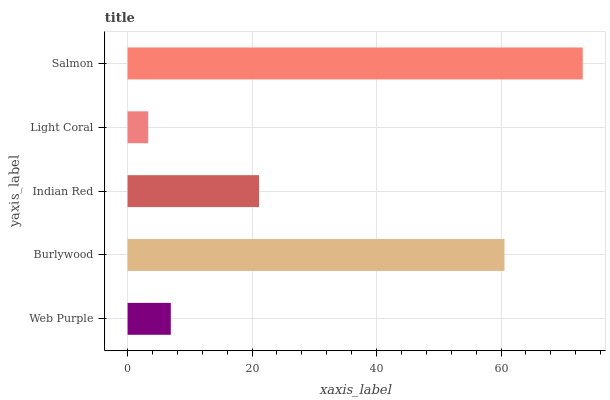Is Light Coral the minimum?
Answer yes or no. Yes. Is Salmon the maximum?
Answer yes or no. Yes. Is Burlywood the minimum?
Answer yes or no. No. Is Burlywood the maximum?
Answer yes or no. No. Is Burlywood greater than Web Purple?
Answer yes or no. Yes. Is Web Purple less than Burlywood?
Answer yes or no. Yes. Is Web Purple greater than Burlywood?
Answer yes or no. No. Is Burlywood less than Web Purple?
Answer yes or no. No. Is Indian Red the high median?
Answer yes or no. Yes. Is Indian Red the low median?
Answer yes or no. Yes. Is Web Purple the high median?
Answer yes or no. No. Is Burlywood the low median?
Answer yes or no. No. 